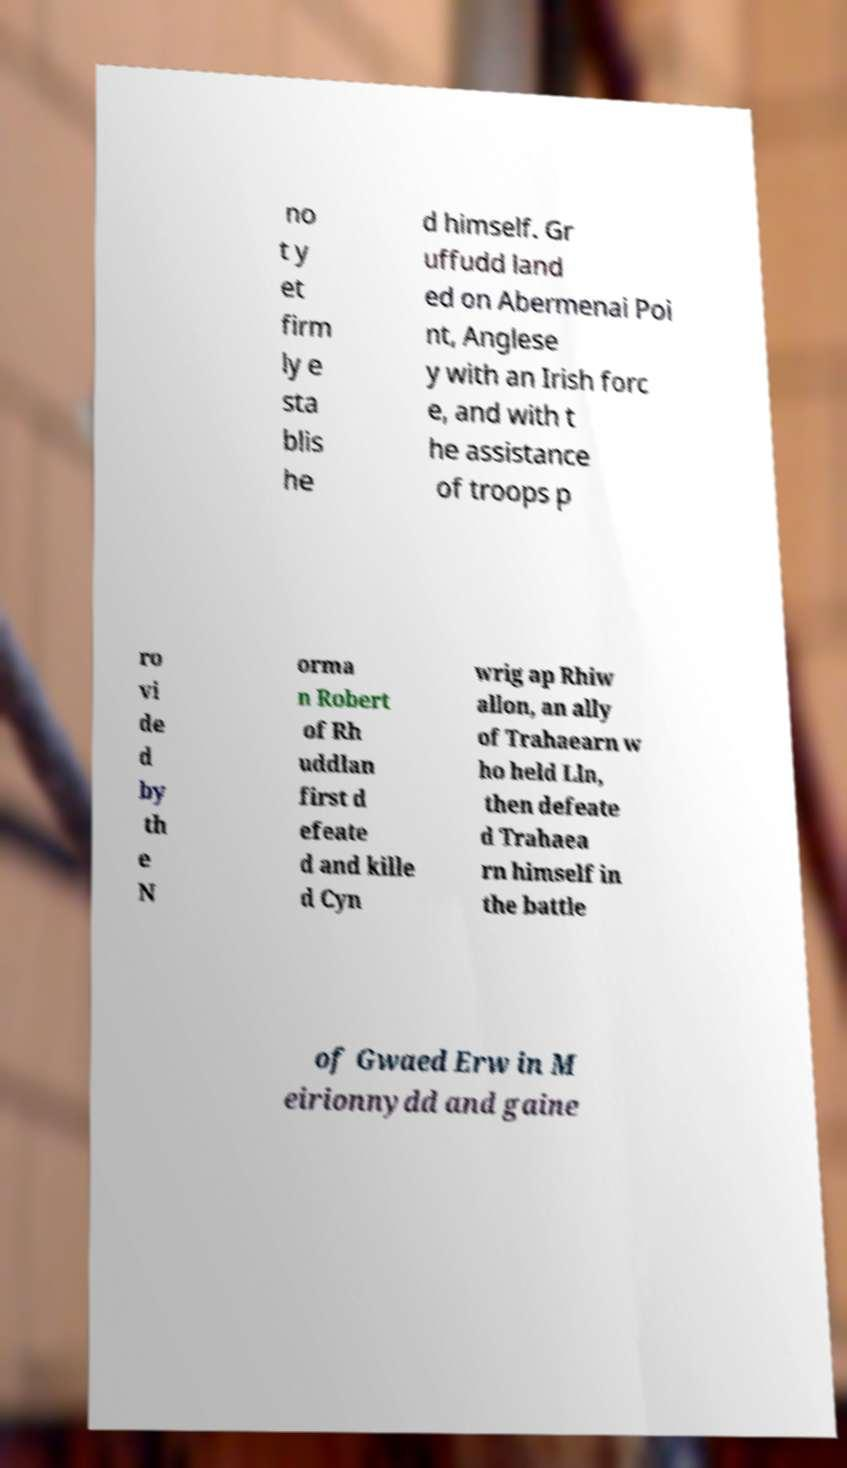Could you assist in decoding the text presented in this image and type it out clearly? no t y et firm ly e sta blis he d himself. Gr uffudd land ed on Abermenai Poi nt, Anglese y with an Irish forc e, and with t he assistance of troops p ro vi de d by th e N orma n Robert of Rh uddlan first d efeate d and kille d Cyn wrig ap Rhiw allon, an ally of Trahaearn w ho held Lln, then defeate d Trahaea rn himself in the battle of Gwaed Erw in M eirionnydd and gaine 